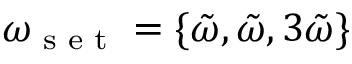Convert formula to latex. <formula><loc_0><loc_0><loc_500><loc_500>\omega _ { s e t } = \{ \tilde { \omega } , \tilde { \omega } , 3 \tilde { \omega } \}</formula> 